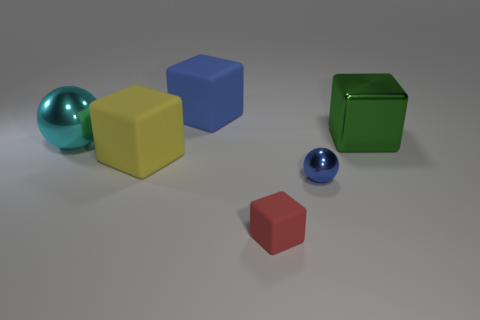Are there fewer green objects than big rubber cubes?
Give a very brief answer. Yes. Is the ball on the left side of the big yellow object made of the same material as the object that is behind the metal cube?
Your answer should be very brief. No. Is the number of yellow rubber objects in front of the tiny blue ball less than the number of red matte cubes?
Ensure brevity in your answer.  Yes. There is a blue object that is to the right of the blue matte thing; what number of big green things are behind it?
Provide a succinct answer. 1. There is a object that is both behind the cyan shiny sphere and on the left side of the small sphere; how big is it?
Provide a succinct answer. Large. Are there any other things that are the same material as the green block?
Offer a very short reply. Yes. Is the tiny ball made of the same material as the blue thing that is behind the metal cube?
Ensure brevity in your answer.  No. Are there fewer small balls behind the large green cube than red things right of the red rubber block?
Ensure brevity in your answer.  No. There is a blue object on the left side of the small blue ball; what is its material?
Provide a short and direct response. Rubber. There is a thing that is to the right of the large blue matte block and to the left of the small shiny ball; what is its color?
Ensure brevity in your answer.  Red. 